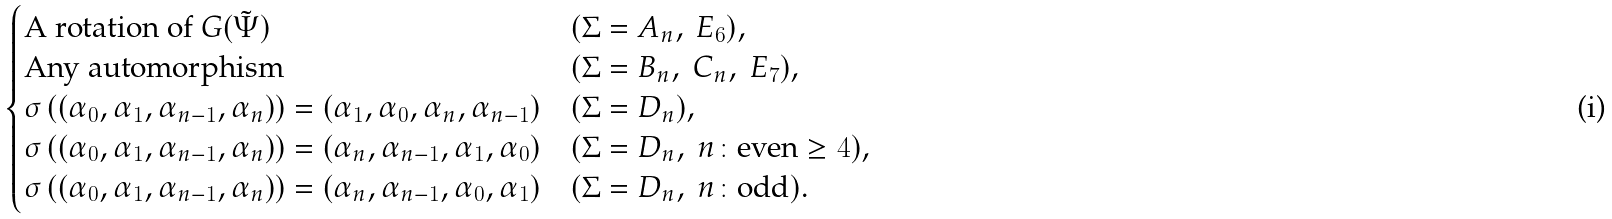Convert formula to latex. <formula><loc_0><loc_0><loc_500><loc_500>\begin{cases} \text {A rotation of } G ( \tilde { \Psi } ) & ( \Sigma = A _ { n } , \ E _ { 6 } ) , \\ \text {Any automorphism} & ( \Sigma = B _ { n } , \ C _ { n } , \ E _ { 7 } ) , \\ \sigma \left ( ( \alpha _ { 0 } , \alpha _ { 1 } , \alpha _ { n - 1 } , \alpha _ { n } ) \right ) = ( \alpha _ { 1 } , \alpha _ { 0 } , \alpha _ { n } , \alpha _ { n - 1 } ) & ( \Sigma = D _ { n } ) , \\ \sigma \left ( ( \alpha _ { 0 } , \alpha _ { 1 } , \alpha _ { n - 1 } , \alpha _ { n } ) \right ) = ( \alpha _ { n } , \alpha _ { n - 1 } , \alpha _ { 1 } , \alpha _ { 0 } ) & ( \Sigma = D _ { n } , \ n \colon \text {even} \geq 4 ) , \\ \sigma \left ( ( \alpha _ { 0 } , \alpha _ { 1 } , \alpha _ { n - 1 } , \alpha _ { n } ) \right ) = ( \alpha _ { n } , \alpha _ { n - 1 } , \alpha _ { 0 } , \alpha _ { 1 } ) & ( \Sigma = D _ { n } , \ n \colon \text {odd} ) . \end{cases}</formula> 